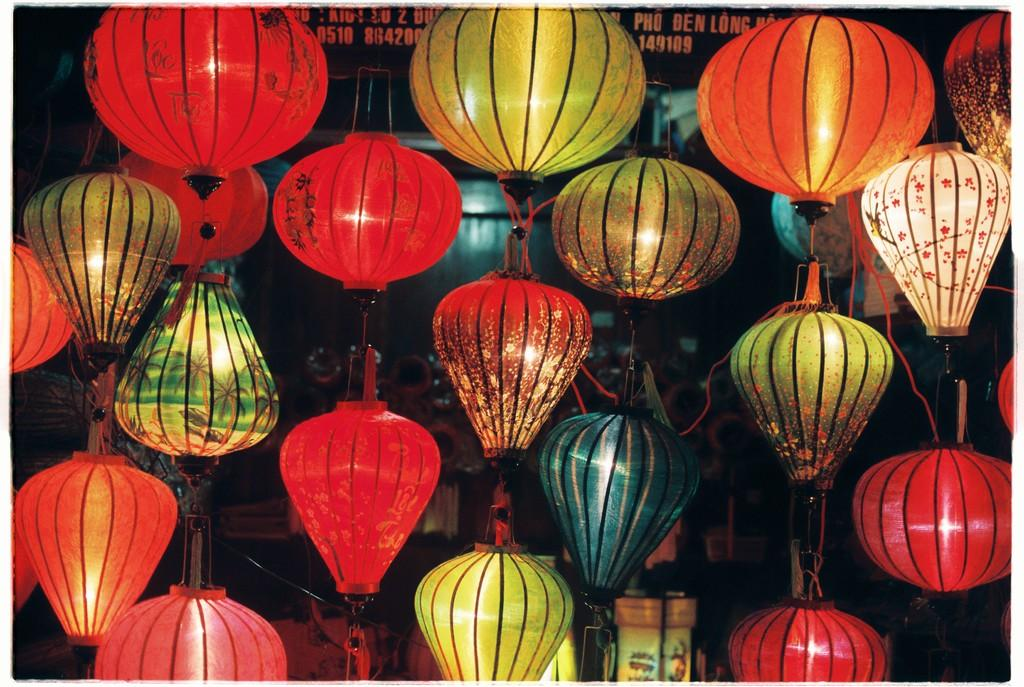What type of objects are present in the image? There are light balls in the image. What colors are the light balls? The light balls are in red, green, and orange colors. Can you describe the background of the image? There are objects visible in the background of the image. What type of gold object is visible on the stage in the image? There is no stage or gold object present in the image; it features light balls in red, green, and orange colors. 